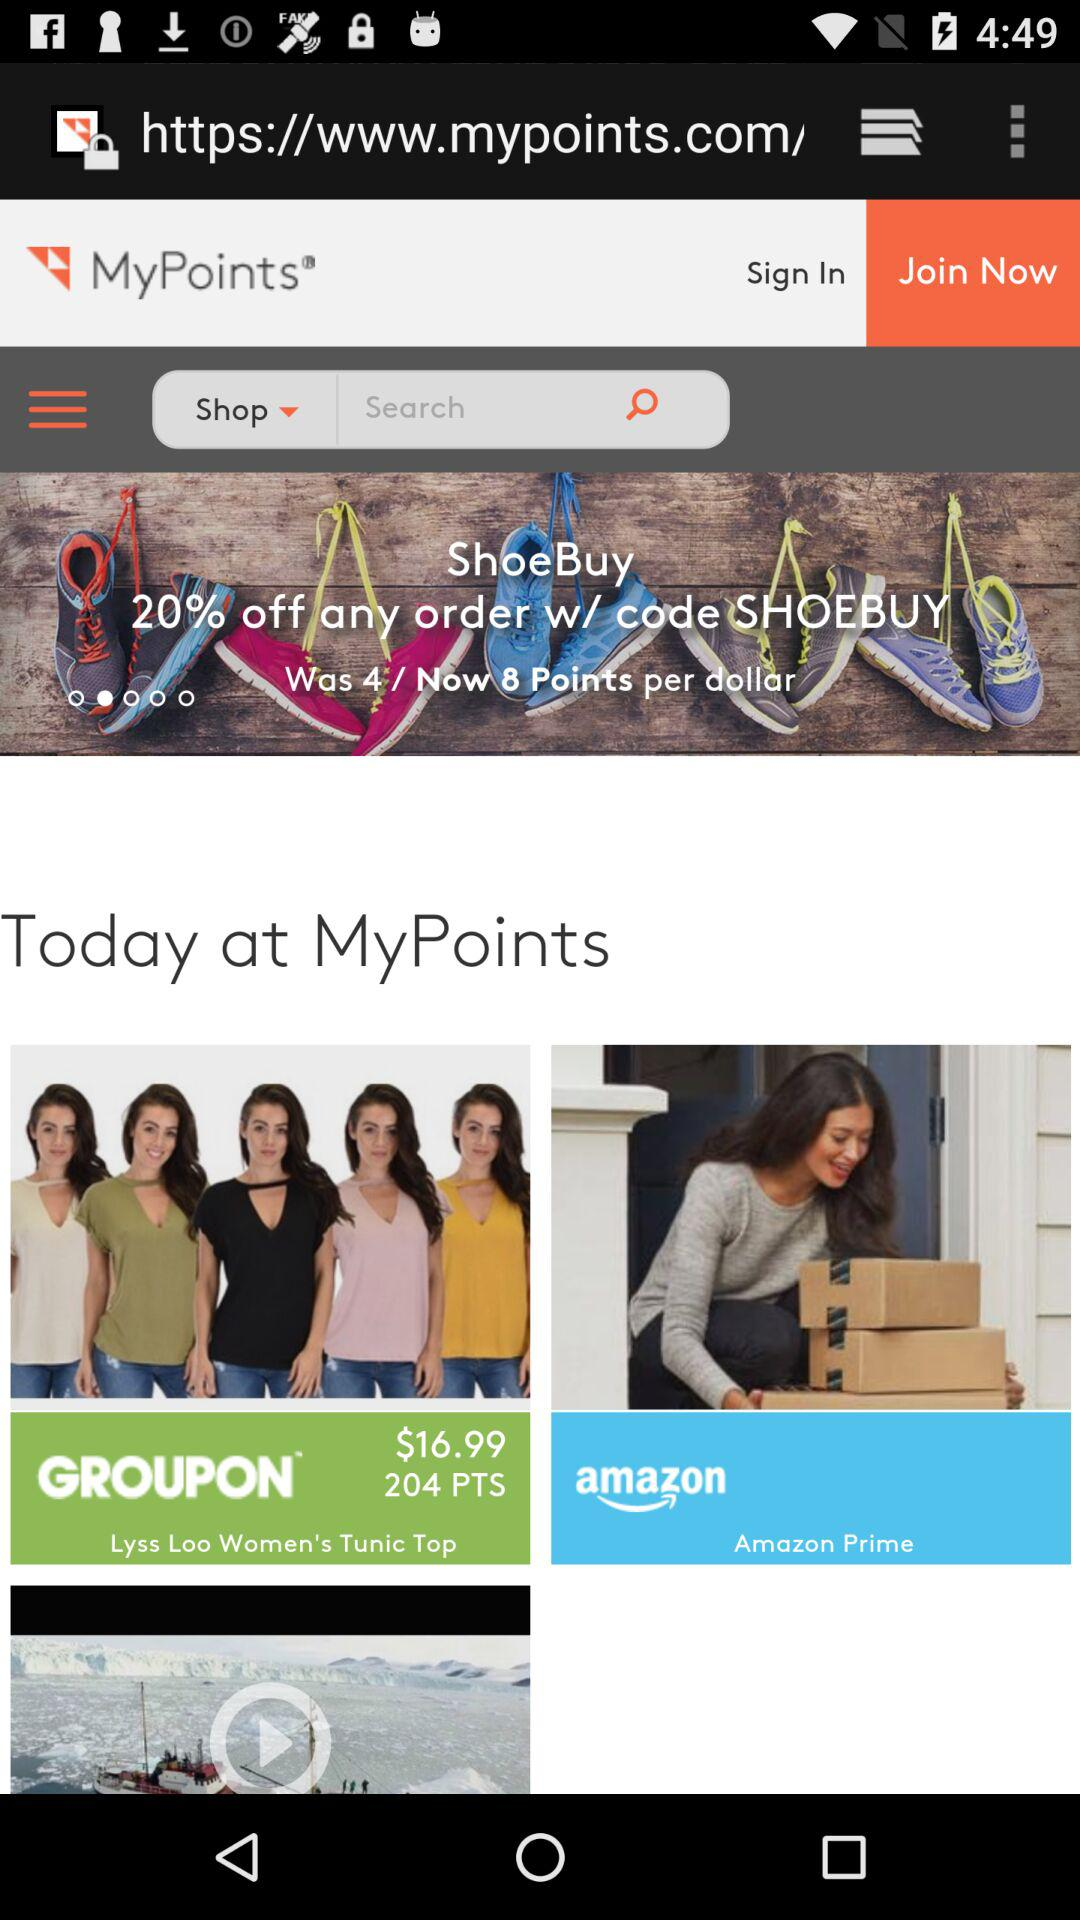What price is mentioned? The mentioned price is $16.99. 